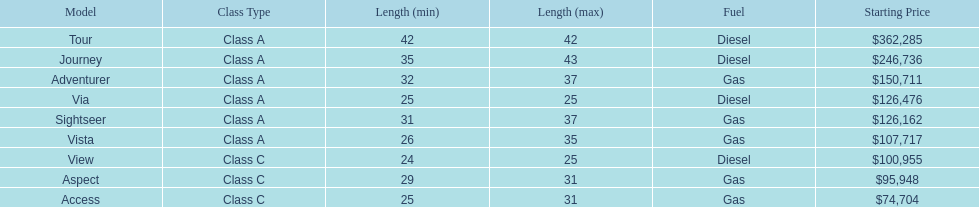Is the vista more than the aspect? Yes. Would you be able to parse every entry in this table? {'header': ['Model', 'Class Type', 'Length (min)', 'Length (max)', 'Fuel', 'Starting Price'], 'rows': [['Tour', 'Class A', '42', '42', 'Diesel', '$362,285'], ['Journey', 'Class A', '35', '43', 'Diesel', '$246,736'], ['Adventurer', 'Class A', '32', '37', 'Gas', '$150,711'], ['Via', 'Class A', '25', '25', 'Diesel', '$126,476'], ['Sightseer', 'Class A', '31', '37', 'Gas', '$126,162'], ['Vista', 'Class A', '26', '35', 'Gas', '$107,717'], ['View', 'Class C', '24', '25', 'Diesel', '$100,955'], ['Aspect', 'Class C', '29', '31', 'Gas', '$95,948'], ['Access', 'Class C', '25', '31', 'Gas', '$74,704']]} 